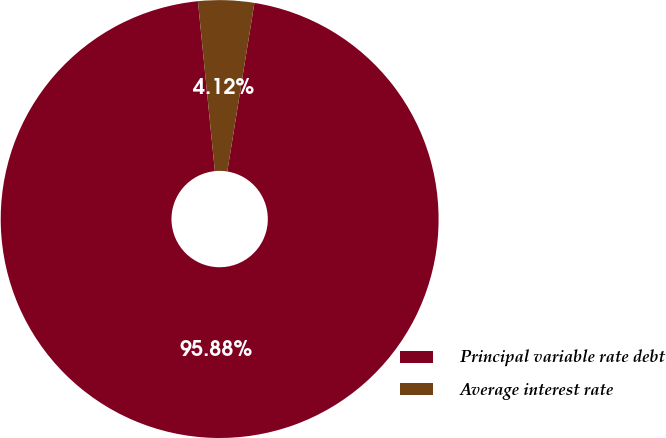Convert chart to OTSL. <chart><loc_0><loc_0><loc_500><loc_500><pie_chart><fcel>Principal variable rate debt<fcel>Average interest rate<nl><fcel>95.88%<fcel>4.12%<nl></chart> 